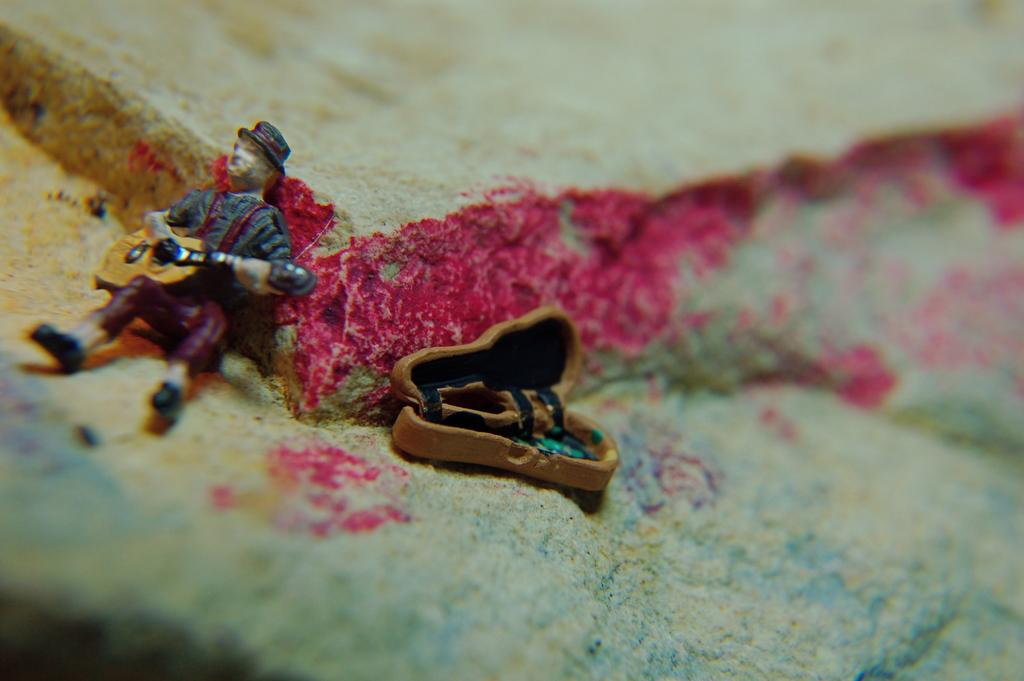What objects are present in the image? There are toys in the image. Where are the toys located? The toys are on a surface. How many chickens can be seen playing with the toys in the image? There are no chickens present in the image; it only features toys on a surface. What type of tooth is visible in the image? There is no tooth present in the image. 